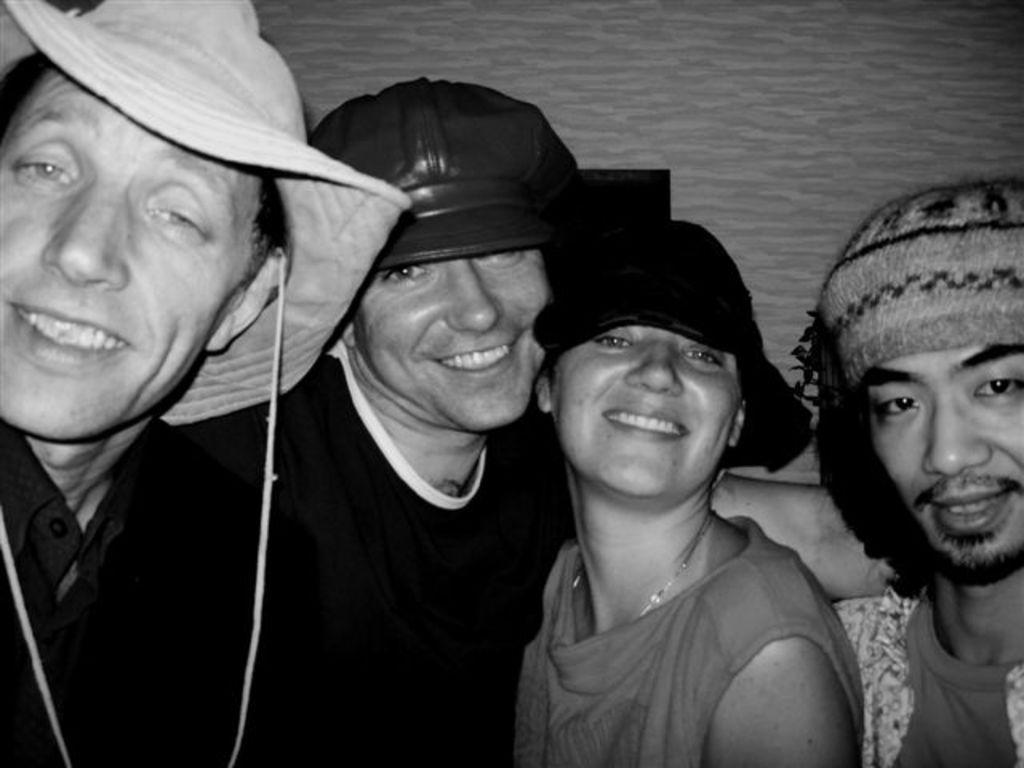Describe this image in one or two sentences. In this image we can see few people and they are wearing hats and caps. There is an object in the image. We can see a wall in the image. 